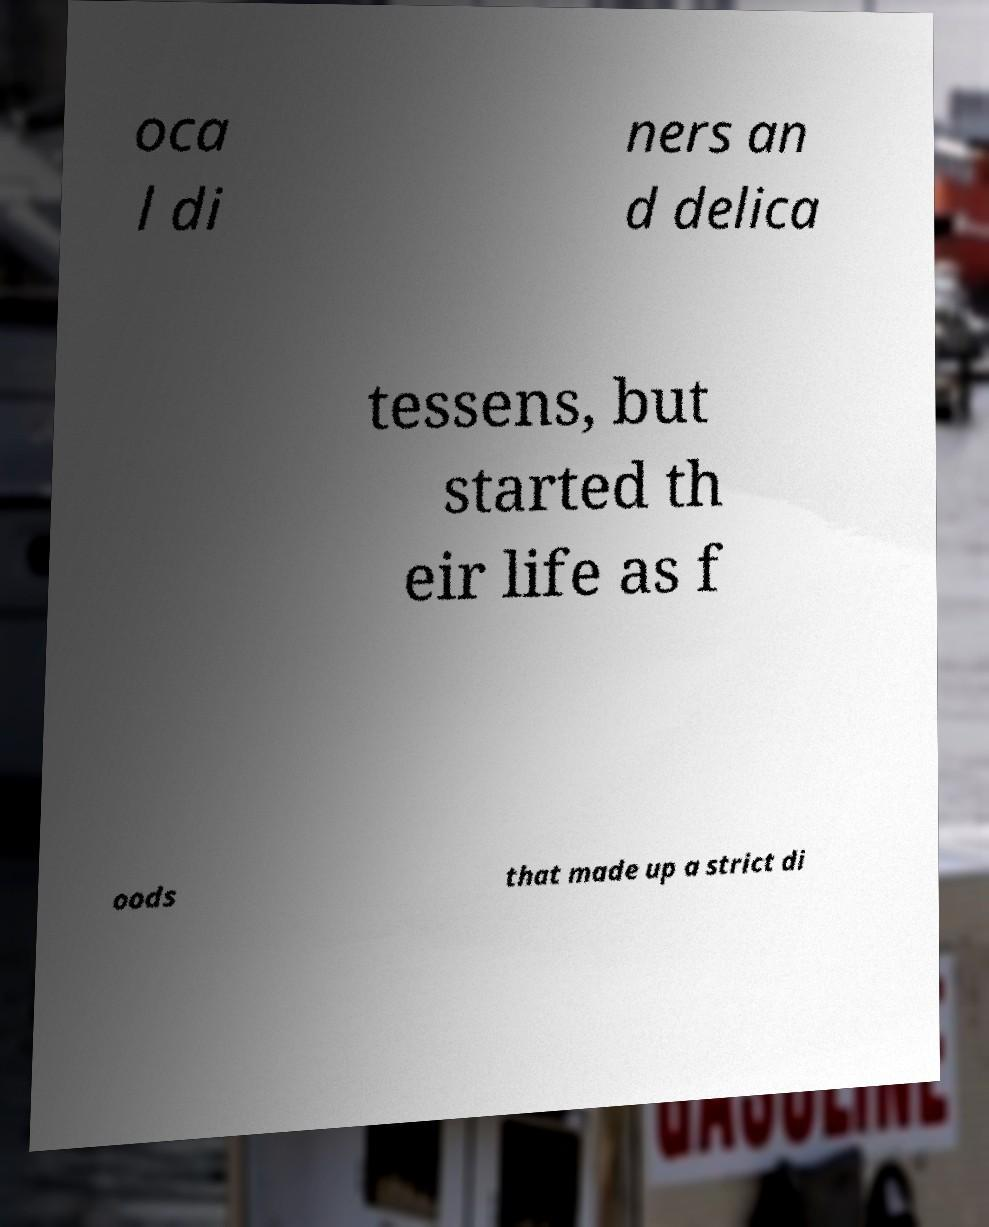There's text embedded in this image that I need extracted. Can you transcribe it verbatim? oca l di ners an d delica tessens, but started th eir life as f oods that made up a strict di 